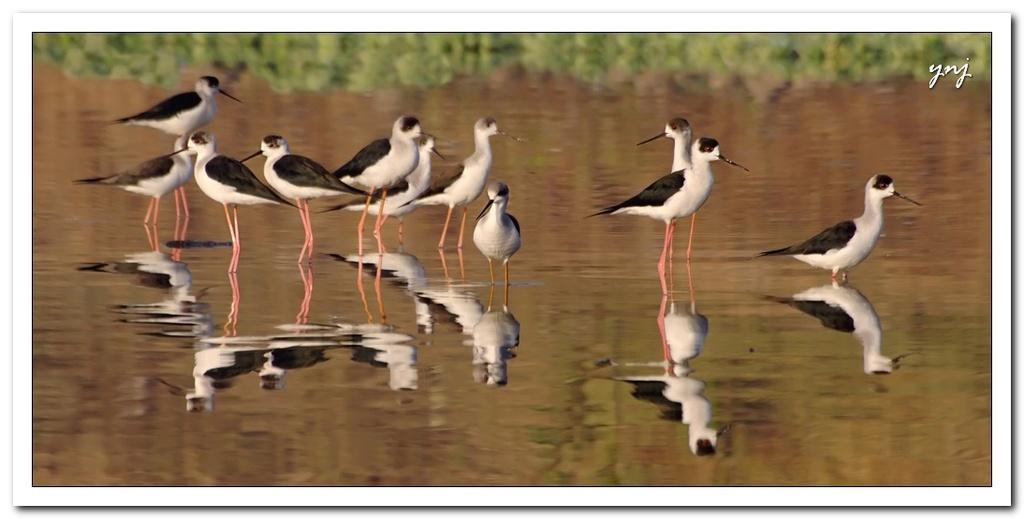What is the main subject of the image? The main subject of the image is a water surface. What can be seen on the water surface? There are birds on the water surface. What is present in the top right corner of the image? There is text in the top right corner of the image. How would you describe the background of the image? The background of the image is blurred. What type of lawyer is depicted in the image? There is no lawyer present in the image; it features a water surface with birds and blurred background. 